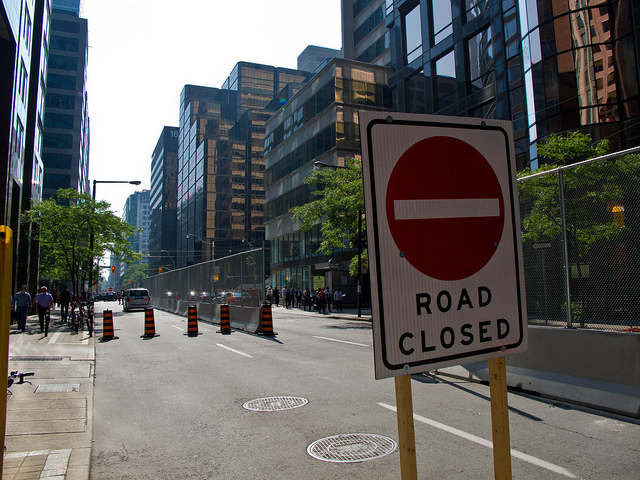<image>What color is the door? There is no clear indication of a door in the image. If there is a door, the color is not identifiable. What color is the door? There is no door in the image. 